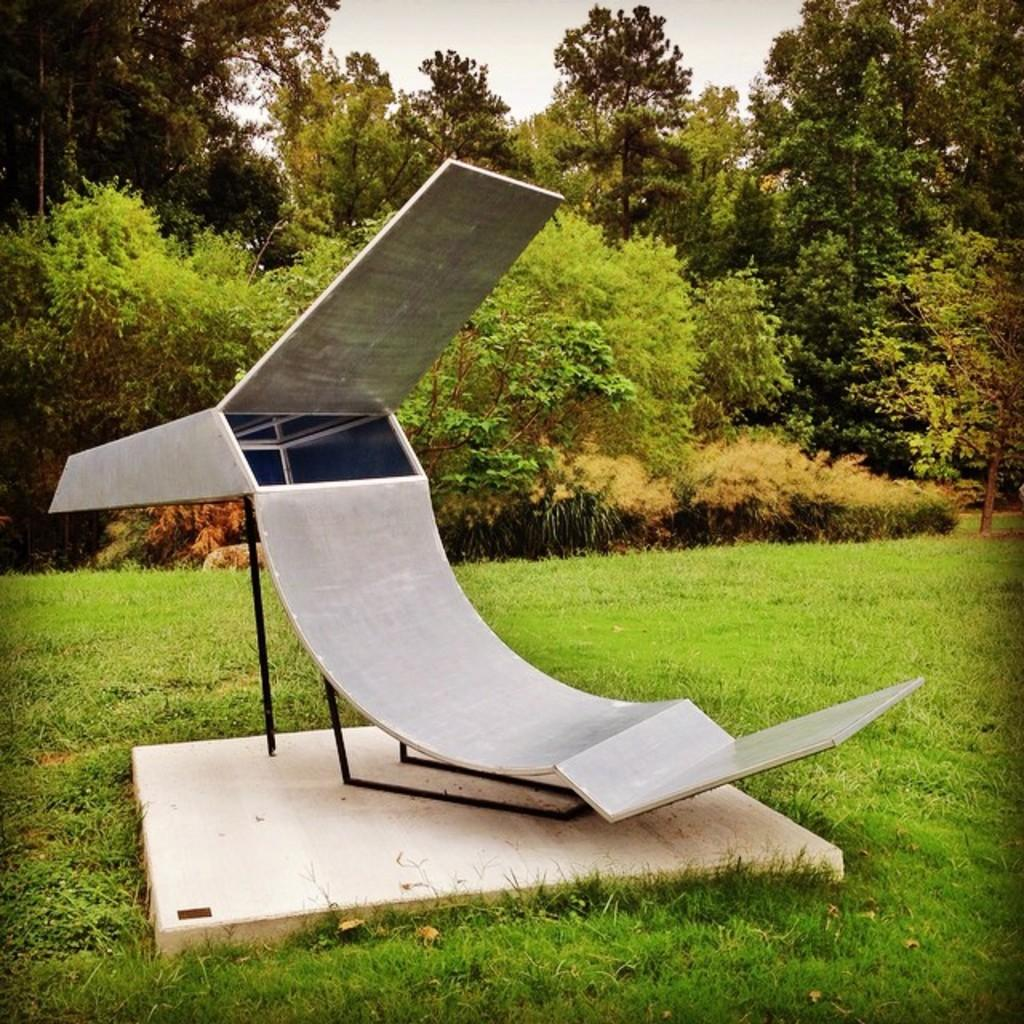What is the main object in the image? There is a slide in the image. What is the slide placed on? The slide is on a stone. What type of surface is the stone on? The stone is in the grass. What can be seen in the background of the image? There are trees and the sky visible in the image. What type of flame can be seen coming from the trees in the image? There is no flame present in the image; it features a slide on a stone in the grass with trees and the sky in the background. 